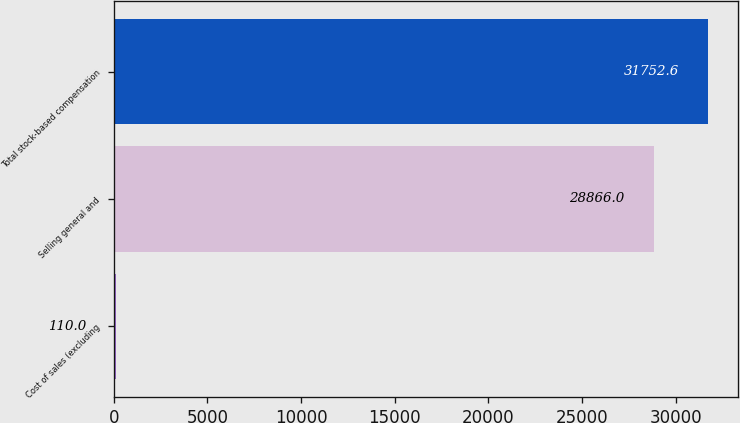Convert chart to OTSL. <chart><loc_0><loc_0><loc_500><loc_500><bar_chart><fcel>Cost of sales (excluding<fcel>Selling general and<fcel>Total stock-based compensation<nl><fcel>110<fcel>28866<fcel>31752.6<nl></chart> 